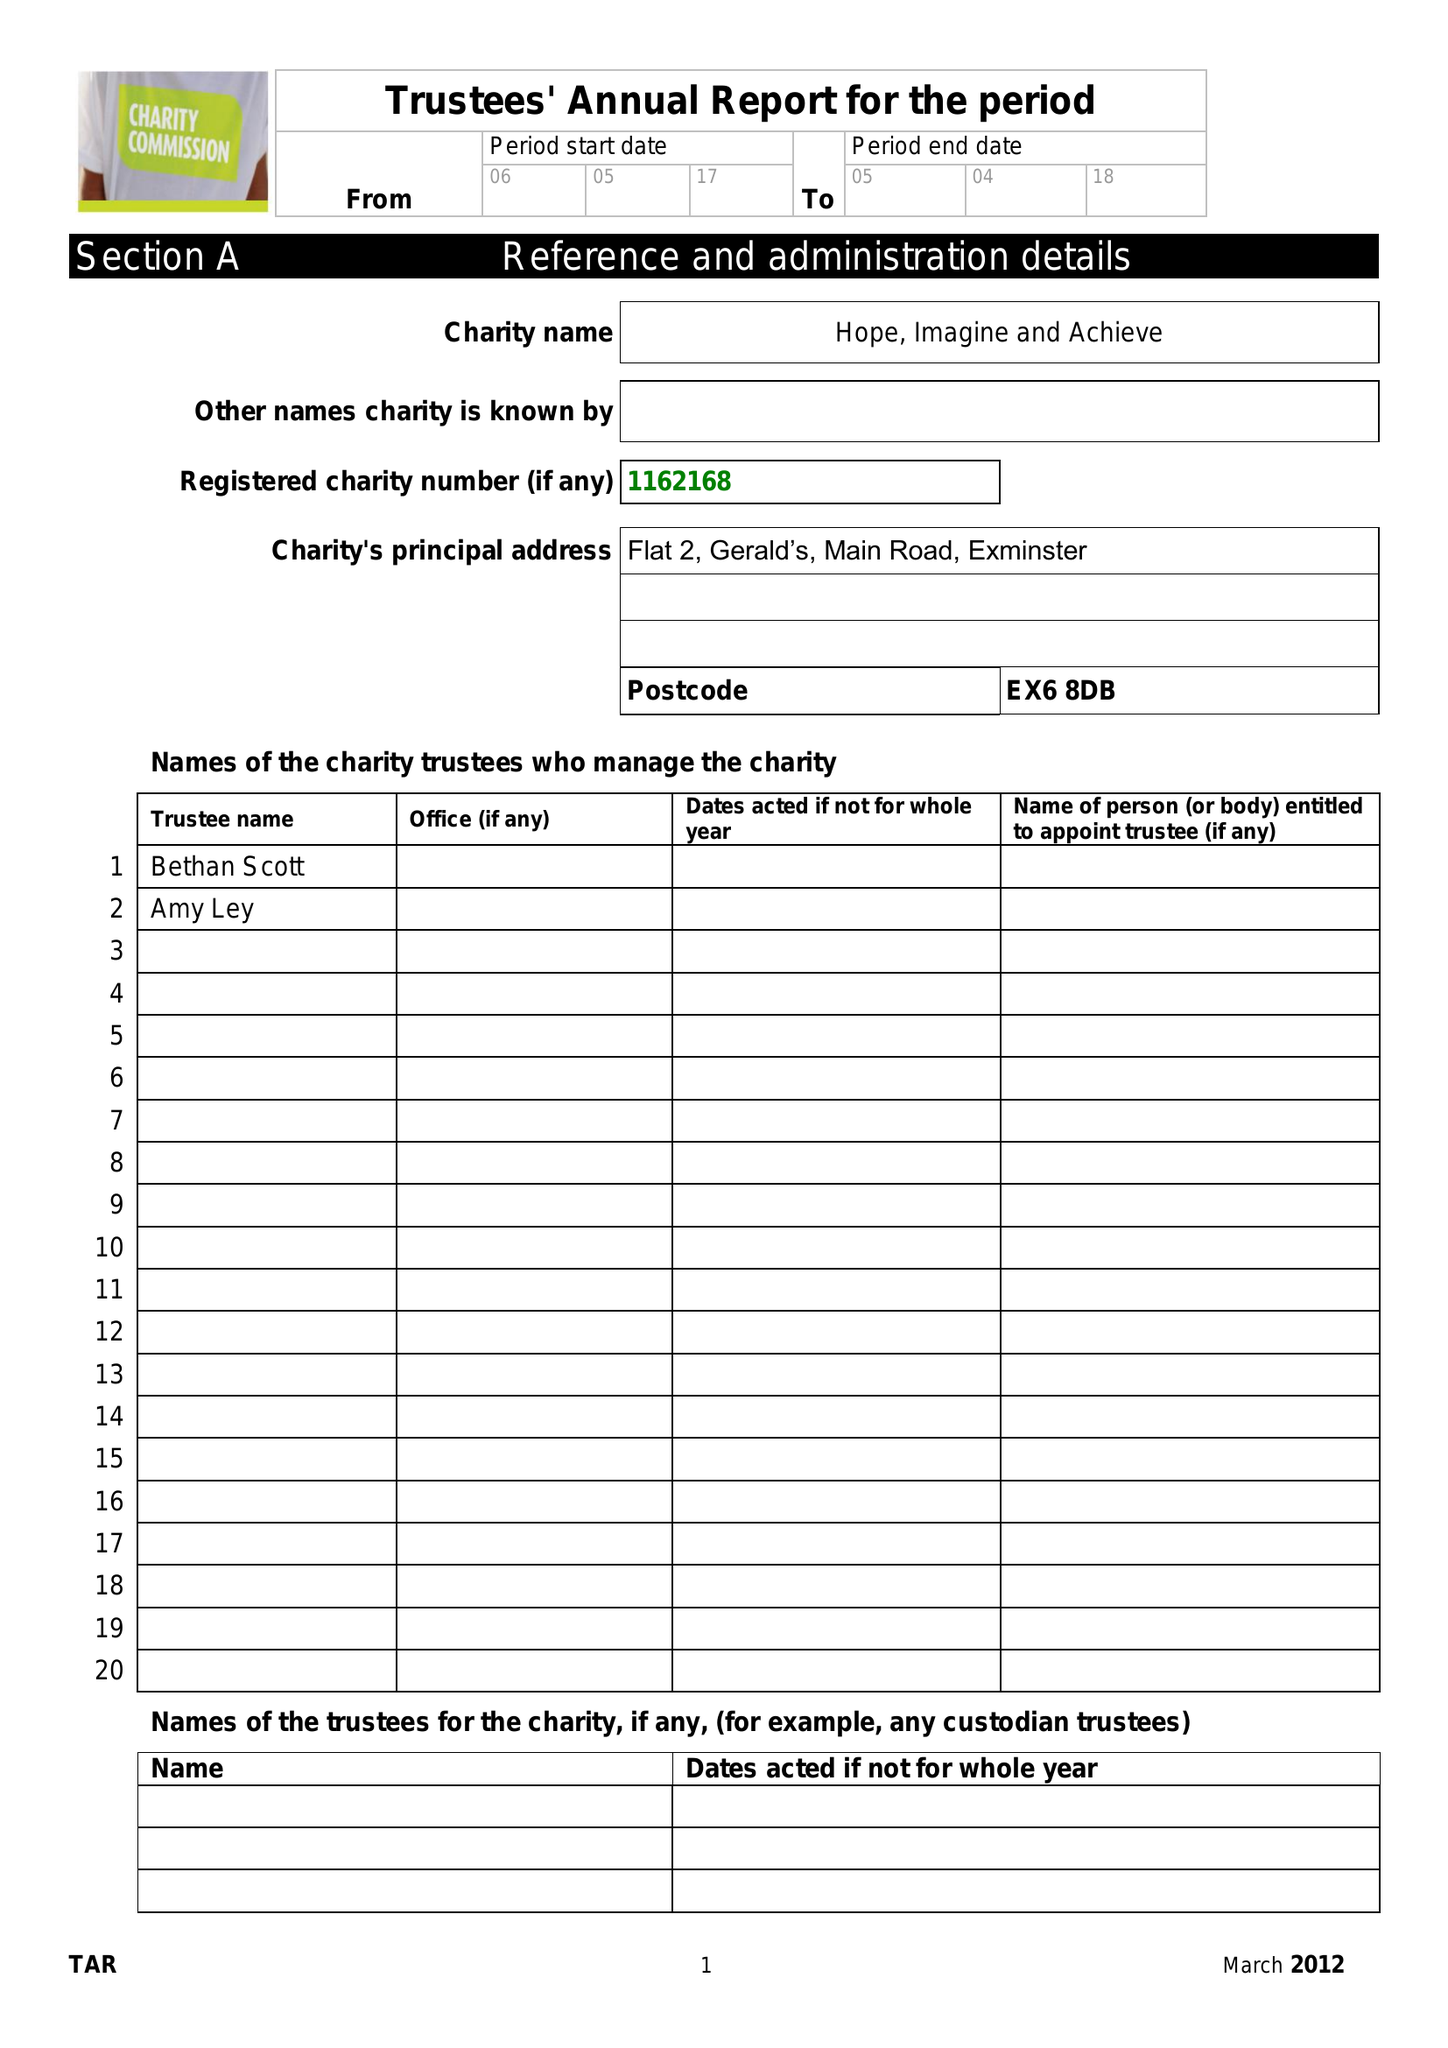What is the value for the charity_number?
Answer the question using a single word or phrase. 1162168 